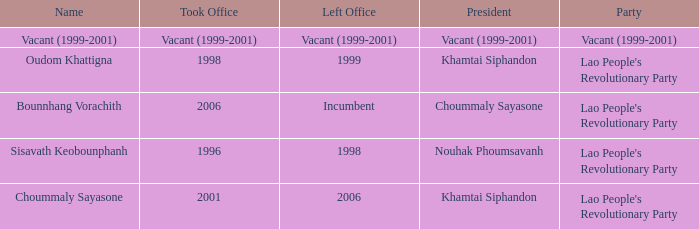What is Party, when Name is Oudom Khattigna? Lao People's Revolutionary Party. 